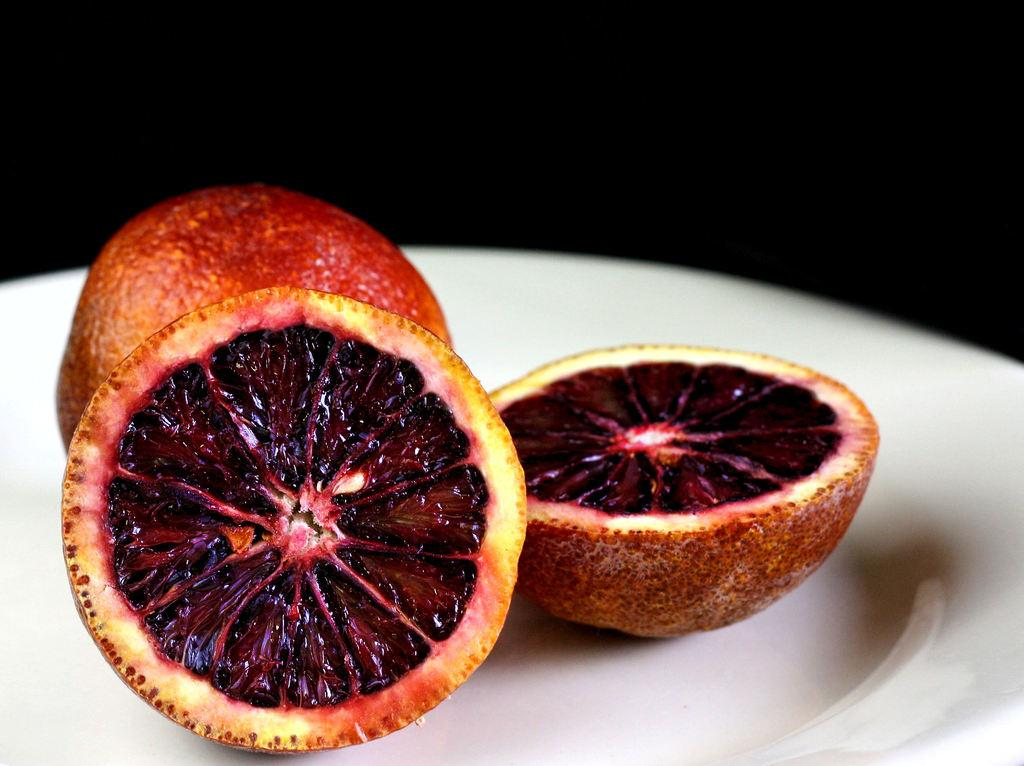What type of food is present in the image? There is a fruit in the image. How is the fruit presented on the plate? There are two slices of the fruit on a plate. What color is the background of the image? The background of the image is black in color. How many mice can be seen eating the fruit in the image? There are no mice present in the image; it only features a fruit and its slices on a plate. 